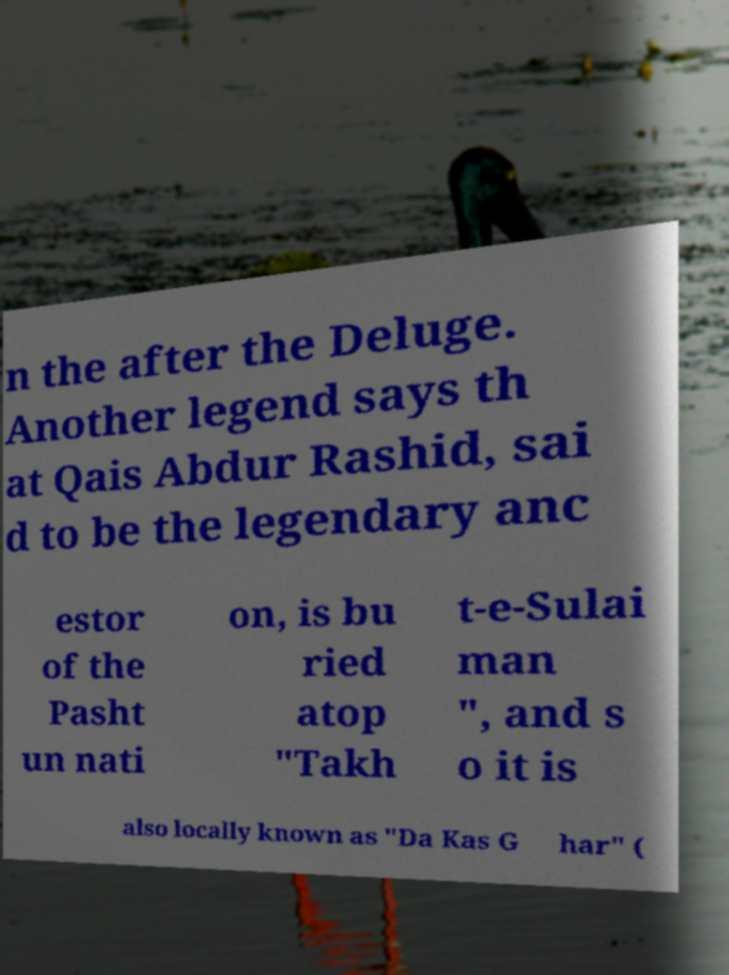What messages or text are displayed in this image? I need them in a readable, typed format. n the after the Deluge. Another legend says th at Qais Abdur Rashid, sai d to be the legendary anc estor of the Pasht un nati on, is bu ried atop "Takh t-e-Sulai man ", and s o it is also locally known as "Da Kas G har" ( 